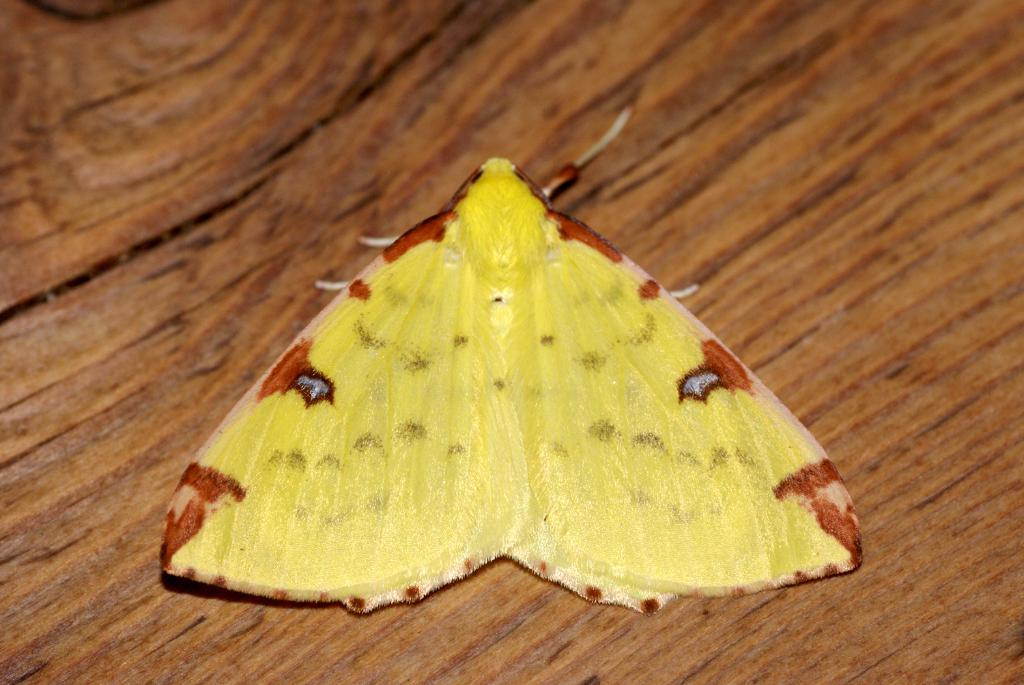What is the main subject of the image? There is a butterfly in the image. Where is the butterfly located in the image? The butterfly is in the center of the image. What surface is the butterfly resting on? The butterfly is on a table. What type of reward is the butterfly receiving for its performance in the image? There is no indication in the image that the butterfly is receiving a reward or performing any actions. 